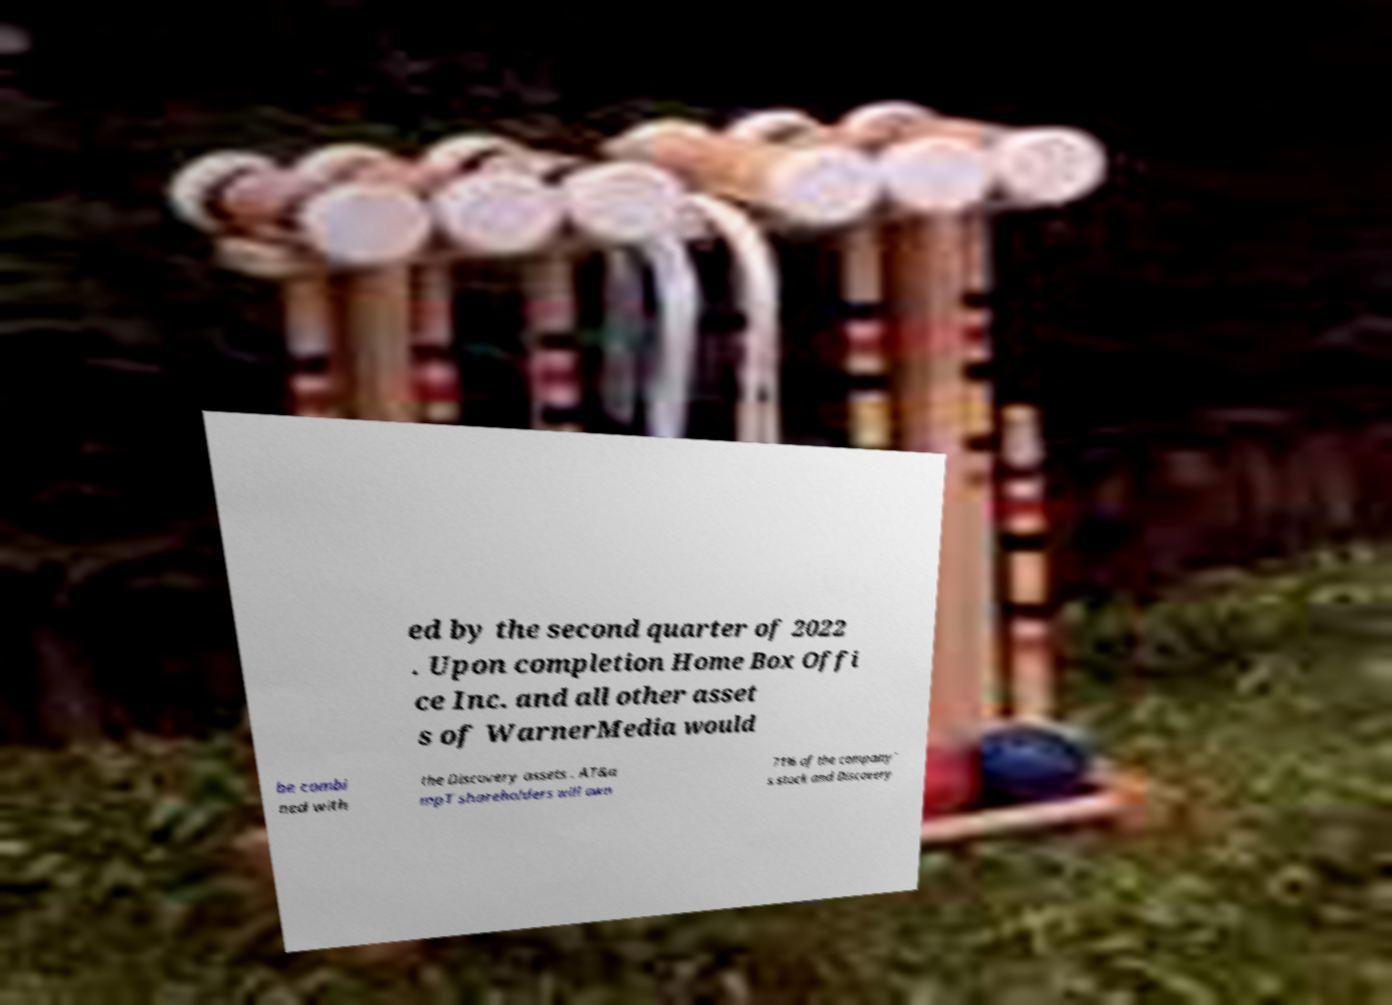Please identify and transcribe the text found in this image. ed by the second quarter of 2022 . Upon completion Home Box Offi ce Inc. and all other asset s of WarnerMedia would be combi ned with the Discovery assets . AT&a mpT shareholders will own 71% of the company’ s stock and Discovery 